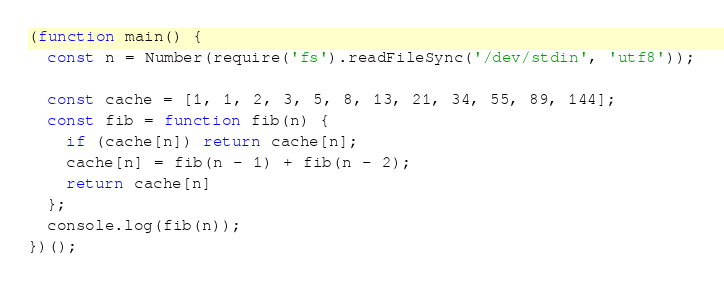<code> <loc_0><loc_0><loc_500><loc_500><_JavaScript_>(function main() {
  const n = Number(require('fs').readFileSync('/dev/stdin', 'utf8'));

  const cache = [1, 1, 2, 3, 5, 8, 13, 21, 34, 55, 89, 144];
  const fib = function fib(n) {
    if (cache[n]) return cache[n];
    cache[n] = fib(n - 1) + fib(n - 2);
    return cache[n]
  };
  console.log(fib(n));
})();

</code> 